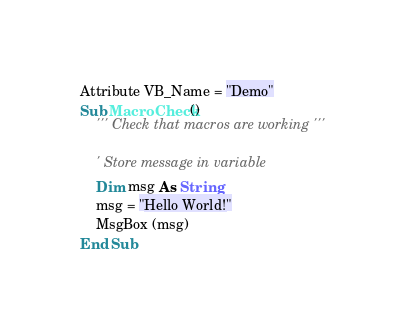<code> <loc_0><loc_0><loc_500><loc_500><_VisualBasic_>Attribute VB_Name = "Demo"
Sub MacroCheck()
    ''' Check that macros are working '''
    
    ' Store message in variable
    Dim msg As String
    msg = "Hello World!"
    MsgBox (msg)
End Sub

</code> 